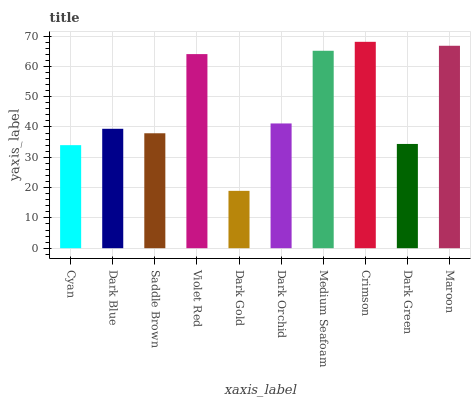Is Dark Gold the minimum?
Answer yes or no. Yes. Is Crimson the maximum?
Answer yes or no. Yes. Is Dark Blue the minimum?
Answer yes or no. No. Is Dark Blue the maximum?
Answer yes or no. No. Is Dark Blue greater than Cyan?
Answer yes or no. Yes. Is Cyan less than Dark Blue?
Answer yes or no. Yes. Is Cyan greater than Dark Blue?
Answer yes or no. No. Is Dark Blue less than Cyan?
Answer yes or no. No. Is Dark Orchid the high median?
Answer yes or no. Yes. Is Dark Blue the low median?
Answer yes or no. Yes. Is Cyan the high median?
Answer yes or no. No. Is Saddle Brown the low median?
Answer yes or no. No. 